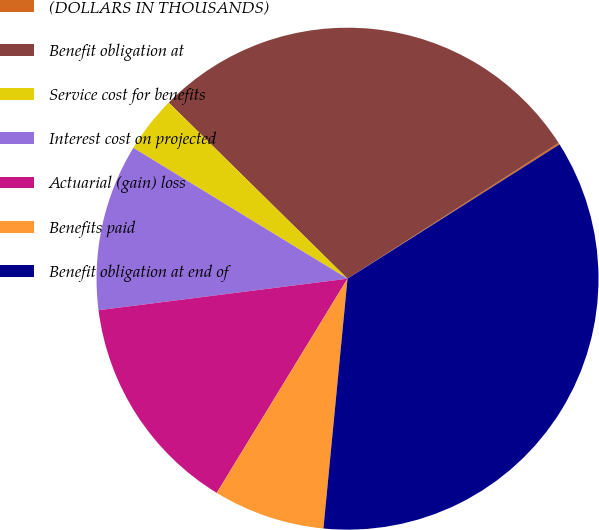Convert chart to OTSL. <chart><loc_0><loc_0><loc_500><loc_500><pie_chart><fcel>(DOLLARS IN THOUSANDS)<fcel>Benefit obligation at<fcel>Service cost for benefits<fcel>Interest cost on projected<fcel>Actuarial (gain) loss<fcel>Benefits paid<fcel>Benefit obligation at end of<nl><fcel>0.11%<fcel>28.52%<fcel>3.65%<fcel>10.73%<fcel>14.27%<fcel>7.19%<fcel>35.51%<nl></chart> 